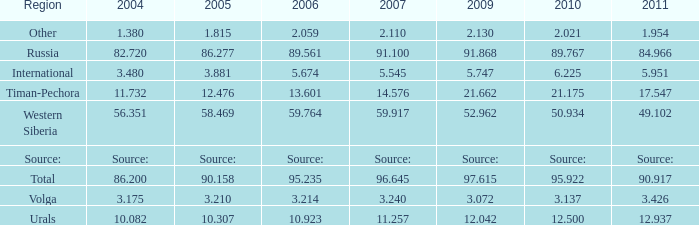What is the 2007 Lukoil oil prodroduction when in 2010 oil production 3.137 million tonnes? 3.24. Can you parse all the data within this table? {'header': ['Region', '2004', '2005', '2006', '2007', '2009', '2010', '2011'], 'rows': [['Other', '1.380', '1.815', '2.059', '2.110', '2.130', '2.021', '1.954'], ['Russia', '82.720', '86.277', '89.561', '91.100', '91.868', '89.767', '84.966'], ['International', '3.480', '3.881', '5.674', '5.545', '5.747', '6.225', '5.951'], ['Timan-Pechora', '11.732', '12.476', '13.601', '14.576', '21.662', '21.175', '17.547'], ['Western Siberia', '56.351', '58.469', '59.764', '59.917', '52.962', '50.934', '49.102'], ['Source:', 'Source:', 'Source:', 'Source:', 'Source:', 'Source:', 'Source:', 'Source:'], ['Total', '86.200', '90.158', '95.235', '96.645', '97.615', '95.922', '90.917'], ['Volga', '3.175', '3.210', '3.214', '3.240', '3.072', '3.137', '3.426'], ['Urals', '10.082', '10.307', '10.923', '11.257', '12.042', '12.500', '12.937']]} 